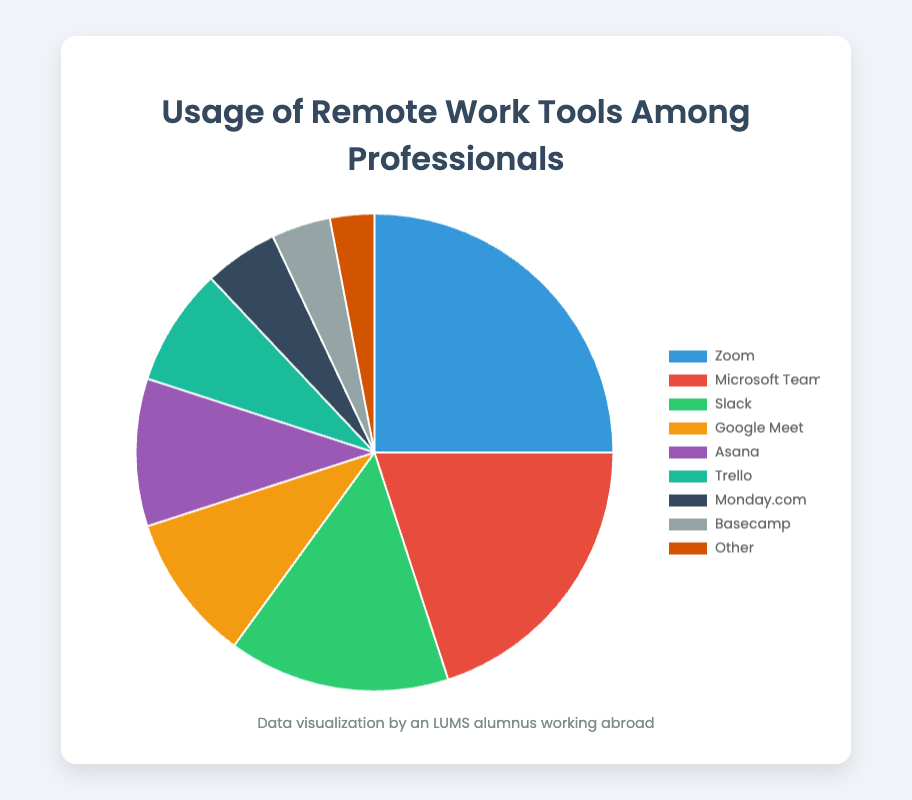What is the most used remote work tool among professionals? The pie chart shows the percentage of usage of various remote work tools. The tool with the highest percentage is the most used. Zoom has the highest percentage at 25%
Answer: Zoom Which tool is used more: Microsoft Teams or Slack? By referring to the pie chart, you can see the usage percentages for both tools. Microsoft Teams has a usage percentage of 20%, while Slack has a usage percentage of 15%. Since 20% is greater than 15%, Microsoft Teams is used more than Slack
Answer: Microsoft Teams What is the combined usage percentage of Google Meet and Asana? The pie chart shows that Google Meet has a usage percentage of 10% and Asana has a usage percentage of 10%. Adding these two percentages together gives 10% + 10% = 20%
Answer: 20% Which tool is represented by the yellow color in the pie chart? In the pie chart, the tool represented by the yellow color has a percentage of 10%. Referring to the data, Google Meet has a usage percentage of 10% and is represented by the yellow color
Answer: Google Meet How does the usage of Trello compare to that of Monday.com? The pie chart shows the usage percentages for both Trello and Monday.com. Trello has a usage percentage of 8%, while Monday.com has a usage percentage of 5%. Trello is used more than Monday.com by 3%
Answer: Trello What is the total percentage of usage for all tools excluding 'Other'? The usage percentages for all tools besides 'Other' are: 25%, 20%, 15%, 10%, 10%, 8%, 5%, and 4%. Adding these together gives 25 + 20 + 15 + 10 + 10 + 8 + 5 + 4 = 97%
Answer: 97% Which tool has the lowest usage among professionals? Referring to the pie chart, the tool with the lowest percentage is Basecamp at 4%, but 'Other' has the lowest with 3%
Answer: Other Is the combined percentage usage of Basecamp and 'Other' less than the usage of Slack? The pie chart shows that Basecamp has a usage percentage of 4% and 'Other' has 3%. Combined, this makes 4% + 3% = 7%. Slack has a usage percentage of 15%. Since 7% is less than 15%, the combined percentage of Basecamp and 'Other' is less than Slack
Answer: Yes What percentage of professionals use either Zoom or Microsoft Teams? Zoom is used by 25% of professionals and Microsoft Teams by 20%. The combined usage percentage is 25% + 20% = 45%
Answer: 45% If the total number of professionals is 1000, how many use Trello? Trello is used by 8% of professionals. To find the number, multiply 1000 by 0.08: 1000 * 0.08 = 80 professionals
Answer: 80 